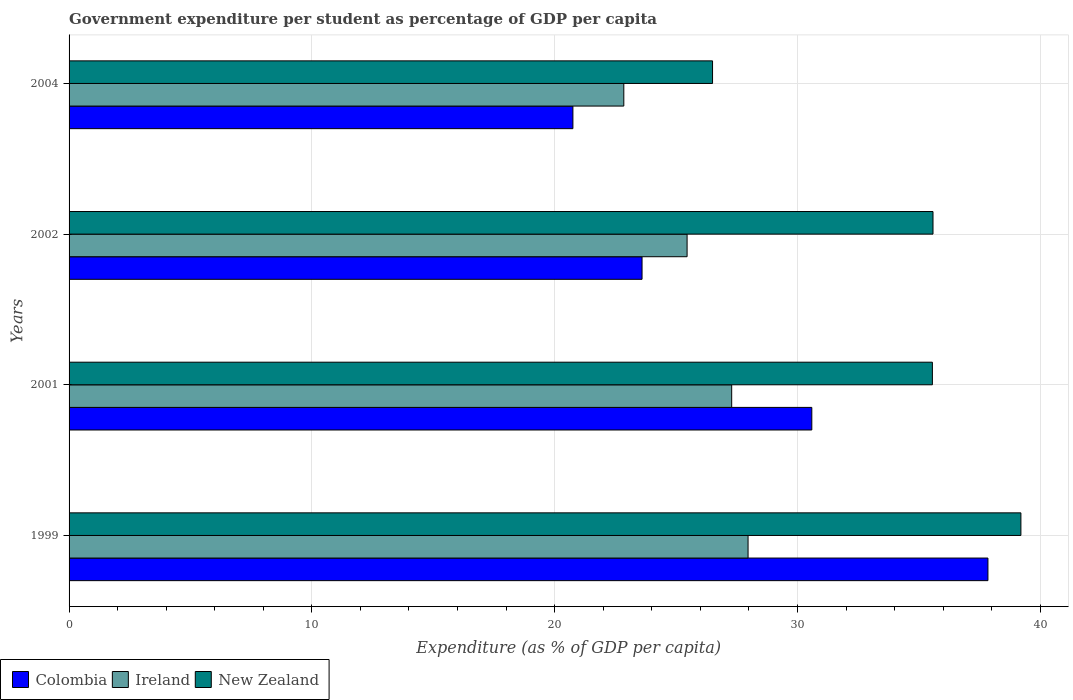How many different coloured bars are there?
Your answer should be very brief. 3. How many groups of bars are there?
Offer a terse response. 4. Are the number of bars per tick equal to the number of legend labels?
Your answer should be compact. Yes. How many bars are there on the 2nd tick from the bottom?
Give a very brief answer. 3. What is the percentage of expenditure per student in New Zealand in 2002?
Your response must be concise. 35.58. Across all years, what is the maximum percentage of expenditure per student in Colombia?
Provide a succinct answer. 37.85. Across all years, what is the minimum percentage of expenditure per student in Ireland?
Make the answer very short. 22.85. In which year was the percentage of expenditure per student in New Zealand minimum?
Provide a succinct answer. 2004. What is the total percentage of expenditure per student in Colombia in the graph?
Your answer should be compact. 112.79. What is the difference between the percentage of expenditure per student in New Zealand in 2002 and that in 2004?
Your response must be concise. 9.08. What is the difference between the percentage of expenditure per student in Colombia in 2004 and the percentage of expenditure per student in Ireland in 2001?
Offer a very short reply. -6.54. What is the average percentage of expenditure per student in New Zealand per year?
Your response must be concise. 34.21. In the year 2001, what is the difference between the percentage of expenditure per student in Colombia and percentage of expenditure per student in Ireland?
Provide a succinct answer. 3.3. In how many years, is the percentage of expenditure per student in New Zealand greater than 28 %?
Make the answer very short. 3. What is the ratio of the percentage of expenditure per student in Ireland in 1999 to that in 2001?
Keep it short and to the point. 1.02. What is the difference between the highest and the second highest percentage of expenditure per student in New Zealand?
Provide a short and direct response. 3.62. What is the difference between the highest and the lowest percentage of expenditure per student in Ireland?
Keep it short and to the point. 5.12. What does the 1st bar from the top in 1999 represents?
Make the answer very short. New Zealand. What does the 1st bar from the bottom in 2002 represents?
Give a very brief answer. Colombia. Are all the bars in the graph horizontal?
Provide a short and direct response. Yes. How many years are there in the graph?
Ensure brevity in your answer.  4. What is the difference between two consecutive major ticks on the X-axis?
Provide a succinct answer. 10. Are the values on the major ticks of X-axis written in scientific E-notation?
Give a very brief answer. No. Does the graph contain any zero values?
Keep it short and to the point. No. Where does the legend appear in the graph?
Provide a short and direct response. Bottom left. How many legend labels are there?
Make the answer very short. 3. How are the legend labels stacked?
Offer a very short reply. Horizontal. What is the title of the graph?
Keep it short and to the point. Government expenditure per student as percentage of GDP per capita. What is the label or title of the X-axis?
Give a very brief answer. Expenditure (as % of GDP per capita). What is the label or title of the Y-axis?
Your answer should be very brief. Years. What is the Expenditure (as % of GDP per capita) in Colombia in 1999?
Give a very brief answer. 37.85. What is the Expenditure (as % of GDP per capita) in Ireland in 1999?
Keep it short and to the point. 27.97. What is the Expenditure (as % of GDP per capita) in New Zealand in 1999?
Make the answer very short. 39.2. What is the Expenditure (as % of GDP per capita) in Colombia in 2001?
Make the answer very short. 30.59. What is the Expenditure (as % of GDP per capita) of Ireland in 2001?
Keep it short and to the point. 27.29. What is the Expenditure (as % of GDP per capita) in New Zealand in 2001?
Ensure brevity in your answer.  35.56. What is the Expenditure (as % of GDP per capita) in Colombia in 2002?
Ensure brevity in your answer.  23.6. What is the Expenditure (as % of GDP per capita) of Ireland in 2002?
Keep it short and to the point. 25.45. What is the Expenditure (as % of GDP per capita) in New Zealand in 2002?
Keep it short and to the point. 35.58. What is the Expenditure (as % of GDP per capita) in Colombia in 2004?
Offer a terse response. 20.75. What is the Expenditure (as % of GDP per capita) of Ireland in 2004?
Your answer should be very brief. 22.85. What is the Expenditure (as % of GDP per capita) of New Zealand in 2004?
Keep it short and to the point. 26.5. Across all years, what is the maximum Expenditure (as % of GDP per capita) in Colombia?
Make the answer very short. 37.85. Across all years, what is the maximum Expenditure (as % of GDP per capita) in Ireland?
Provide a short and direct response. 27.97. Across all years, what is the maximum Expenditure (as % of GDP per capita) in New Zealand?
Keep it short and to the point. 39.2. Across all years, what is the minimum Expenditure (as % of GDP per capita) of Colombia?
Your answer should be very brief. 20.75. Across all years, what is the minimum Expenditure (as % of GDP per capita) of Ireland?
Ensure brevity in your answer.  22.85. Across all years, what is the minimum Expenditure (as % of GDP per capita) in New Zealand?
Your answer should be compact. 26.5. What is the total Expenditure (as % of GDP per capita) of Colombia in the graph?
Keep it short and to the point. 112.79. What is the total Expenditure (as % of GDP per capita) in Ireland in the graph?
Provide a succinct answer. 103.56. What is the total Expenditure (as % of GDP per capita) in New Zealand in the graph?
Make the answer very short. 136.85. What is the difference between the Expenditure (as % of GDP per capita) in Colombia in 1999 and that in 2001?
Your answer should be very brief. 7.25. What is the difference between the Expenditure (as % of GDP per capita) in Ireland in 1999 and that in 2001?
Give a very brief answer. 0.67. What is the difference between the Expenditure (as % of GDP per capita) of New Zealand in 1999 and that in 2001?
Ensure brevity in your answer.  3.65. What is the difference between the Expenditure (as % of GDP per capita) in Colombia in 1999 and that in 2002?
Offer a terse response. 14.25. What is the difference between the Expenditure (as % of GDP per capita) in Ireland in 1999 and that in 2002?
Keep it short and to the point. 2.51. What is the difference between the Expenditure (as % of GDP per capita) of New Zealand in 1999 and that in 2002?
Give a very brief answer. 3.62. What is the difference between the Expenditure (as % of GDP per capita) of Colombia in 1999 and that in 2004?
Offer a very short reply. 17.09. What is the difference between the Expenditure (as % of GDP per capita) in Ireland in 1999 and that in 2004?
Provide a succinct answer. 5.12. What is the difference between the Expenditure (as % of GDP per capita) of New Zealand in 1999 and that in 2004?
Offer a very short reply. 12.7. What is the difference between the Expenditure (as % of GDP per capita) of Colombia in 2001 and that in 2002?
Give a very brief answer. 6.99. What is the difference between the Expenditure (as % of GDP per capita) of Ireland in 2001 and that in 2002?
Offer a very short reply. 1.84. What is the difference between the Expenditure (as % of GDP per capita) in New Zealand in 2001 and that in 2002?
Provide a succinct answer. -0.03. What is the difference between the Expenditure (as % of GDP per capita) in Colombia in 2001 and that in 2004?
Ensure brevity in your answer.  9.84. What is the difference between the Expenditure (as % of GDP per capita) of Ireland in 2001 and that in 2004?
Your answer should be compact. 4.44. What is the difference between the Expenditure (as % of GDP per capita) of New Zealand in 2001 and that in 2004?
Provide a succinct answer. 9.06. What is the difference between the Expenditure (as % of GDP per capita) of Colombia in 2002 and that in 2004?
Your answer should be compact. 2.85. What is the difference between the Expenditure (as % of GDP per capita) of Ireland in 2002 and that in 2004?
Provide a succinct answer. 2.61. What is the difference between the Expenditure (as % of GDP per capita) of New Zealand in 2002 and that in 2004?
Offer a very short reply. 9.08. What is the difference between the Expenditure (as % of GDP per capita) of Colombia in 1999 and the Expenditure (as % of GDP per capita) of Ireland in 2001?
Make the answer very short. 10.55. What is the difference between the Expenditure (as % of GDP per capita) in Colombia in 1999 and the Expenditure (as % of GDP per capita) in New Zealand in 2001?
Keep it short and to the point. 2.29. What is the difference between the Expenditure (as % of GDP per capita) of Ireland in 1999 and the Expenditure (as % of GDP per capita) of New Zealand in 2001?
Provide a short and direct response. -7.59. What is the difference between the Expenditure (as % of GDP per capita) in Colombia in 1999 and the Expenditure (as % of GDP per capita) in Ireland in 2002?
Your response must be concise. 12.39. What is the difference between the Expenditure (as % of GDP per capita) of Colombia in 1999 and the Expenditure (as % of GDP per capita) of New Zealand in 2002?
Your response must be concise. 2.26. What is the difference between the Expenditure (as % of GDP per capita) of Ireland in 1999 and the Expenditure (as % of GDP per capita) of New Zealand in 2002?
Make the answer very short. -7.62. What is the difference between the Expenditure (as % of GDP per capita) in Colombia in 1999 and the Expenditure (as % of GDP per capita) in Ireland in 2004?
Offer a very short reply. 15. What is the difference between the Expenditure (as % of GDP per capita) of Colombia in 1999 and the Expenditure (as % of GDP per capita) of New Zealand in 2004?
Offer a very short reply. 11.34. What is the difference between the Expenditure (as % of GDP per capita) of Ireland in 1999 and the Expenditure (as % of GDP per capita) of New Zealand in 2004?
Make the answer very short. 1.46. What is the difference between the Expenditure (as % of GDP per capita) in Colombia in 2001 and the Expenditure (as % of GDP per capita) in Ireland in 2002?
Offer a terse response. 5.14. What is the difference between the Expenditure (as % of GDP per capita) in Colombia in 2001 and the Expenditure (as % of GDP per capita) in New Zealand in 2002?
Provide a short and direct response. -4.99. What is the difference between the Expenditure (as % of GDP per capita) of Ireland in 2001 and the Expenditure (as % of GDP per capita) of New Zealand in 2002?
Your answer should be compact. -8.29. What is the difference between the Expenditure (as % of GDP per capita) in Colombia in 2001 and the Expenditure (as % of GDP per capita) in Ireland in 2004?
Your answer should be compact. 7.74. What is the difference between the Expenditure (as % of GDP per capita) of Colombia in 2001 and the Expenditure (as % of GDP per capita) of New Zealand in 2004?
Make the answer very short. 4.09. What is the difference between the Expenditure (as % of GDP per capita) of Ireland in 2001 and the Expenditure (as % of GDP per capita) of New Zealand in 2004?
Keep it short and to the point. 0.79. What is the difference between the Expenditure (as % of GDP per capita) in Colombia in 2002 and the Expenditure (as % of GDP per capita) in Ireland in 2004?
Offer a very short reply. 0.75. What is the difference between the Expenditure (as % of GDP per capita) of Colombia in 2002 and the Expenditure (as % of GDP per capita) of New Zealand in 2004?
Keep it short and to the point. -2.9. What is the difference between the Expenditure (as % of GDP per capita) in Ireland in 2002 and the Expenditure (as % of GDP per capita) in New Zealand in 2004?
Offer a very short reply. -1.05. What is the average Expenditure (as % of GDP per capita) in Colombia per year?
Ensure brevity in your answer.  28.2. What is the average Expenditure (as % of GDP per capita) of Ireland per year?
Offer a terse response. 25.89. What is the average Expenditure (as % of GDP per capita) of New Zealand per year?
Offer a terse response. 34.21. In the year 1999, what is the difference between the Expenditure (as % of GDP per capita) in Colombia and Expenditure (as % of GDP per capita) in Ireland?
Make the answer very short. 9.88. In the year 1999, what is the difference between the Expenditure (as % of GDP per capita) of Colombia and Expenditure (as % of GDP per capita) of New Zealand?
Offer a very short reply. -1.36. In the year 1999, what is the difference between the Expenditure (as % of GDP per capita) in Ireland and Expenditure (as % of GDP per capita) in New Zealand?
Provide a short and direct response. -11.24. In the year 2001, what is the difference between the Expenditure (as % of GDP per capita) in Colombia and Expenditure (as % of GDP per capita) in Ireland?
Keep it short and to the point. 3.3. In the year 2001, what is the difference between the Expenditure (as % of GDP per capita) of Colombia and Expenditure (as % of GDP per capita) of New Zealand?
Give a very brief answer. -4.97. In the year 2001, what is the difference between the Expenditure (as % of GDP per capita) of Ireland and Expenditure (as % of GDP per capita) of New Zealand?
Your response must be concise. -8.27. In the year 2002, what is the difference between the Expenditure (as % of GDP per capita) of Colombia and Expenditure (as % of GDP per capita) of Ireland?
Offer a very short reply. -1.86. In the year 2002, what is the difference between the Expenditure (as % of GDP per capita) of Colombia and Expenditure (as % of GDP per capita) of New Zealand?
Provide a short and direct response. -11.98. In the year 2002, what is the difference between the Expenditure (as % of GDP per capita) in Ireland and Expenditure (as % of GDP per capita) in New Zealand?
Provide a succinct answer. -10.13. In the year 2004, what is the difference between the Expenditure (as % of GDP per capita) of Colombia and Expenditure (as % of GDP per capita) of Ireland?
Your response must be concise. -2.1. In the year 2004, what is the difference between the Expenditure (as % of GDP per capita) of Colombia and Expenditure (as % of GDP per capita) of New Zealand?
Keep it short and to the point. -5.75. In the year 2004, what is the difference between the Expenditure (as % of GDP per capita) of Ireland and Expenditure (as % of GDP per capita) of New Zealand?
Ensure brevity in your answer.  -3.65. What is the ratio of the Expenditure (as % of GDP per capita) in Colombia in 1999 to that in 2001?
Offer a terse response. 1.24. What is the ratio of the Expenditure (as % of GDP per capita) in Ireland in 1999 to that in 2001?
Give a very brief answer. 1.02. What is the ratio of the Expenditure (as % of GDP per capita) in New Zealand in 1999 to that in 2001?
Give a very brief answer. 1.1. What is the ratio of the Expenditure (as % of GDP per capita) of Colombia in 1999 to that in 2002?
Provide a short and direct response. 1.6. What is the ratio of the Expenditure (as % of GDP per capita) of Ireland in 1999 to that in 2002?
Offer a very short reply. 1.1. What is the ratio of the Expenditure (as % of GDP per capita) of New Zealand in 1999 to that in 2002?
Keep it short and to the point. 1.1. What is the ratio of the Expenditure (as % of GDP per capita) in Colombia in 1999 to that in 2004?
Provide a short and direct response. 1.82. What is the ratio of the Expenditure (as % of GDP per capita) of Ireland in 1999 to that in 2004?
Ensure brevity in your answer.  1.22. What is the ratio of the Expenditure (as % of GDP per capita) in New Zealand in 1999 to that in 2004?
Give a very brief answer. 1.48. What is the ratio of the Expenditure (as % of GDP per capita) of Colombia in 2001 to that in 2002?
Ensure brevity in your answer.  1.3. What is the ratio of the Expenditure (as % of GDP per capita) in Ireland in 2001 to that in 2002?
Give a very brief answer. 1.07. What is the ratio of the Expenditure (as % of GDP per capita) of Colombia in 2001 to that in 2004?
Your response must be concise. 1.47. What is the ratio of the Expenditure (as % of GDP per capita) in Ireland in 2001 to that in 2004?
Your response must be concise. 1.19. What is the ratio of the Expenditure (as % of GDP per capita) of New Zealand in 2001 to that in 2004?
Your response must be concise. 1.34. What is the ratio of the Expenditure (as % of GDP per capita) in Colombia in 2002 to that in 2004?
Ensure brevity in your answer.  1.14. What is the ratio of the Expenditure (as % of GDP per capita) in Ireland in 2002 to that in 2004?
Keep it short and to the point. 1.11. What is the ratio of the Expenditure (as % of GDP per capita) of New Zealand in 2002 to that in 2004?
Give a very brief answer. 1.34. What is the difference between the highest and the second highest Expenditure (as % of GDP per capita) of Colombia?
Offer a very short reply. 7.25. What is the difference between the highest and the second highest Expenditure (as % of GDP per capita) of Ireland?
Your response must be concise. 0.67. What is the difference between the highest and the second highest Expenditure (as % of GDP per capita) of New Zealand?
Your answer should be compact. 3.62. What is the difference between the highest and the lowest Expenditure (as % of GDP per capita) in Colombia?
Provide a short and direct response. 17.09. What is the difference between the highest and the lowest Expenditure (as % of GDP per capita) in Ireland?
Make the answer very short. 5.12. What is the difference between the highest and the lowest Expenditure (as % of GDP per capita) of New Zealand?
Your answer should be very brief. 12.7. 